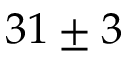<formula> <loc_0><loc_0><loc_500><loc_500>3 1 \pm 3</formula> 